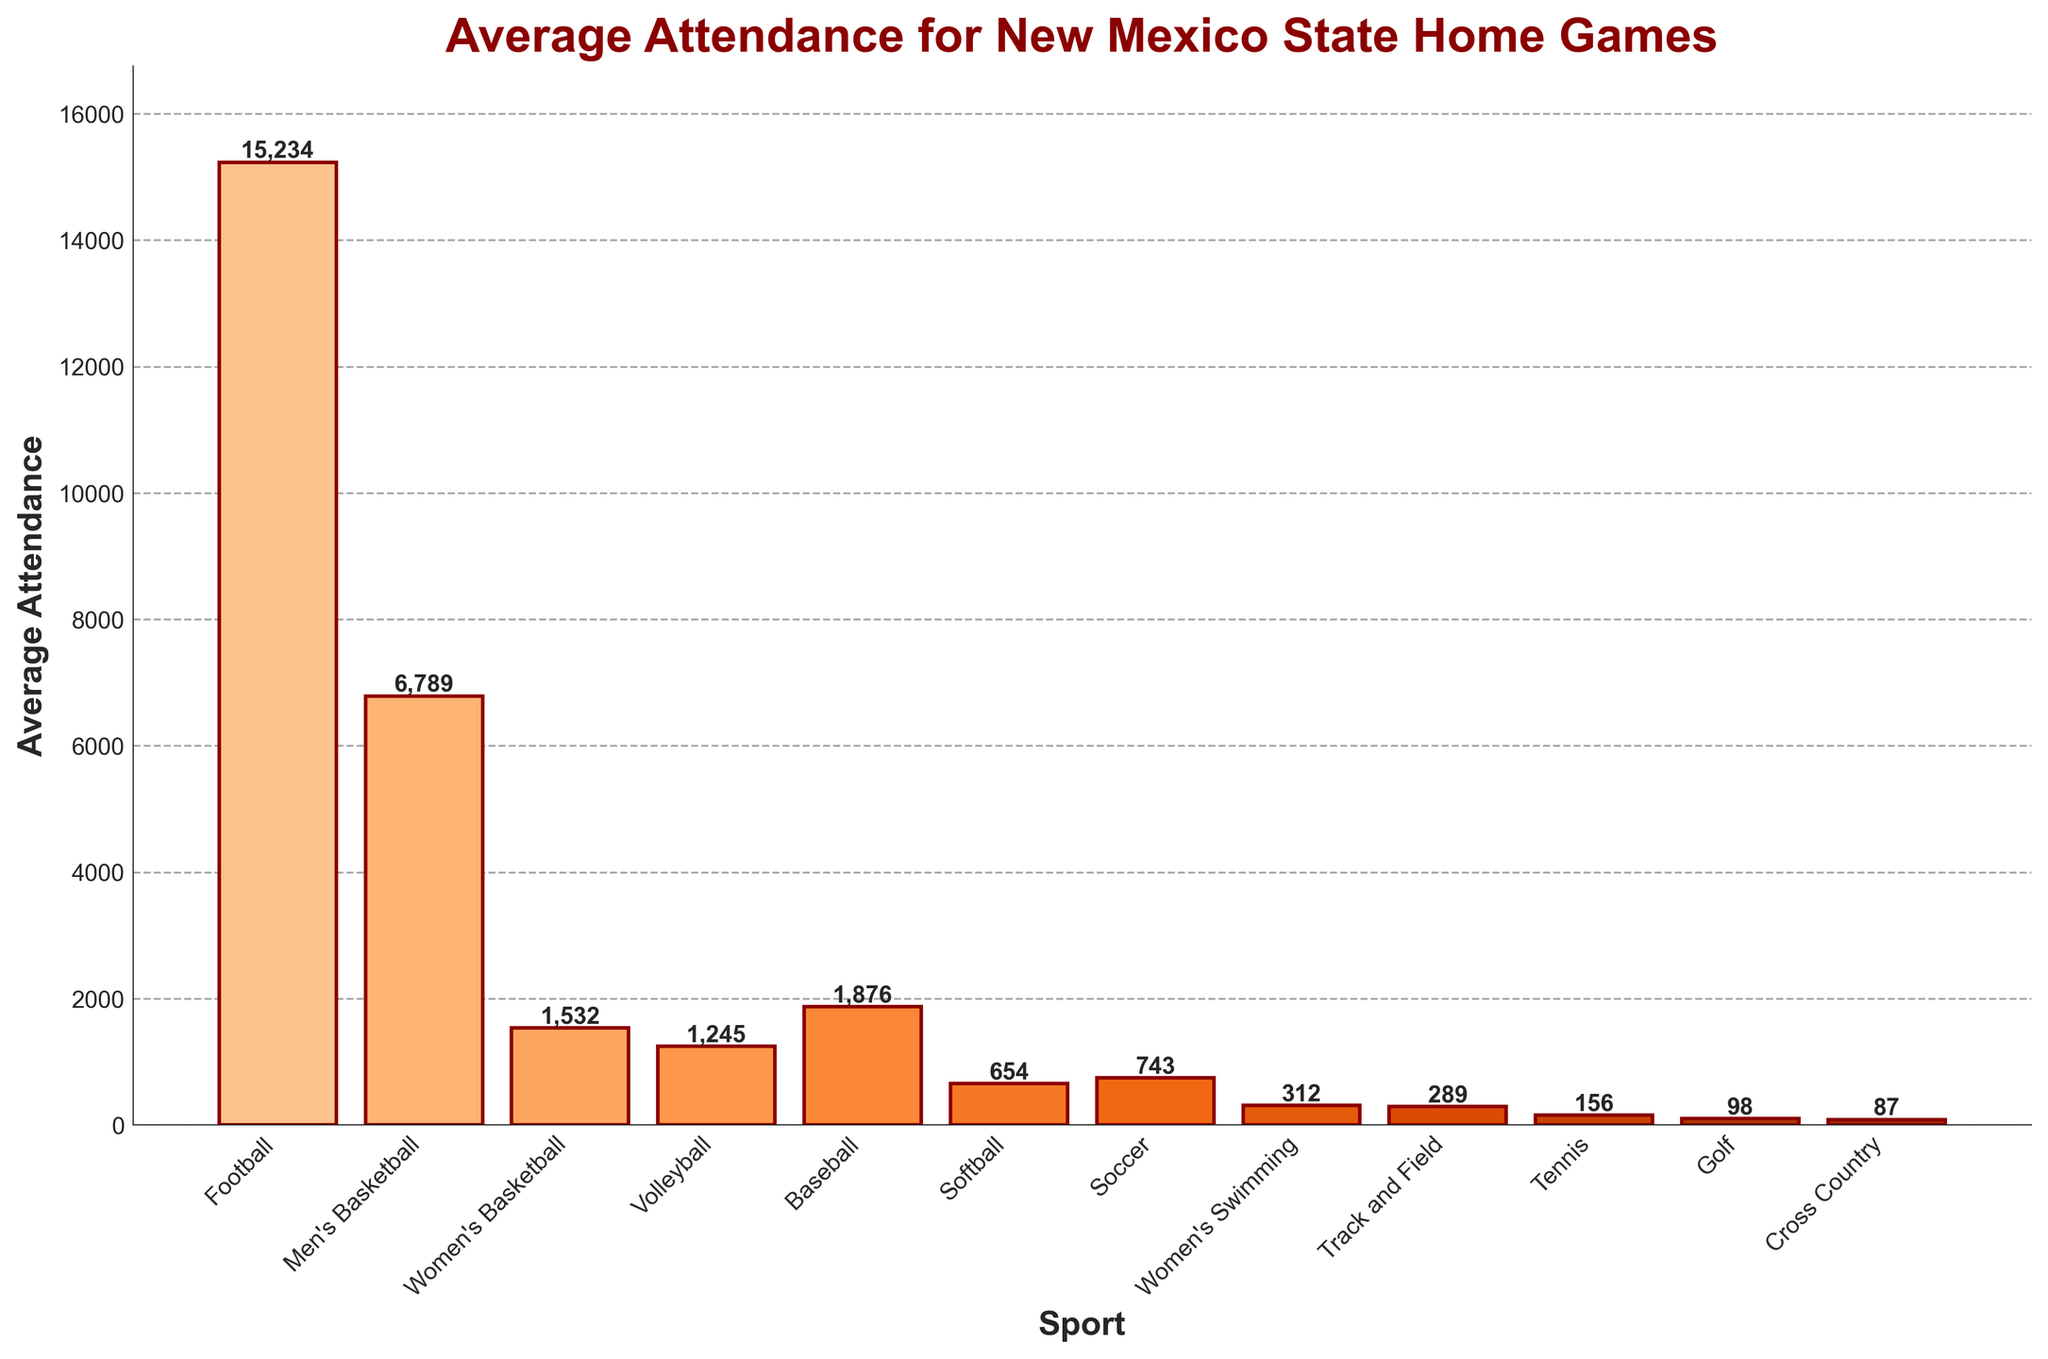Which sport has the highest average attendance? By looking at the height of the bars in the chart, the bar for Football is the tallest, indicating the highest average attendance.
Answer: Football Which two sports have the closest average attendance figures? From the chart, Baseball and Women's Basketball have very close bar heights, indicating similar average attendance figures.
Answer: Baseball, Women's Basketball What is the average attendance for the top three sports combined? The top three sports by average attendance are Football (15,234), Men's Basketball (6,789), and Women's Basketball (1,532). Summing these gives 15,234 + 6,789 + 1,532 = 23,555.
Answer: 23,555 How much more is the average attendance for Football than for Men's Basketball? The average attendance for Football is 15,234, and for Men's Basketball, it is 6,789. The difference is 15,234 - 6,789 = 8,445.
Answer: 8,445 Which sport has the lowest average attendance and what is the value? The chart shows that Cross Country has the smallest bar, indicating it has the lowest average attendance, which is 87.
Answer: Cross Country, 87 What percentage of the total attendance does Football represent? First, find the total attendance by summing all bars: 15,234 + 6,789 + 1,532 + 1,245 + 1,876 + 654 + 743 + 312 + 289 + 156 + 98 + 87 = 28,015. The percentage for Football is (15,234 / 28,015) * 100 ≈ 54.4%.
Answer: 54.4% How does the average attendance for Volleyball compare to that for Baseball? From the chart, Volleyball has an average attendance of 1,245, while Baseball has an attendance of 1,876. 1,245 is less than 1,876.
Answer: Less What is the cumulative average attendance for all women's sports? Summing the average attendance for Women's Basketball (1,532), Volleyball (1,245), Softball (654), Soccer (743), and Women's Swimming (312) gives 1,532 + 1,245 + 654 + 743 + 312 = 4,486.
Answer: 4,486 What is the range of average attendances across all sports? The range is the difference between the highest and lowest attendance figures. The highest is Football with 15,234 and the lowest is Cross Country with 87. The range is 15,234 - 87 = 15,147.
Answer: 15,147 